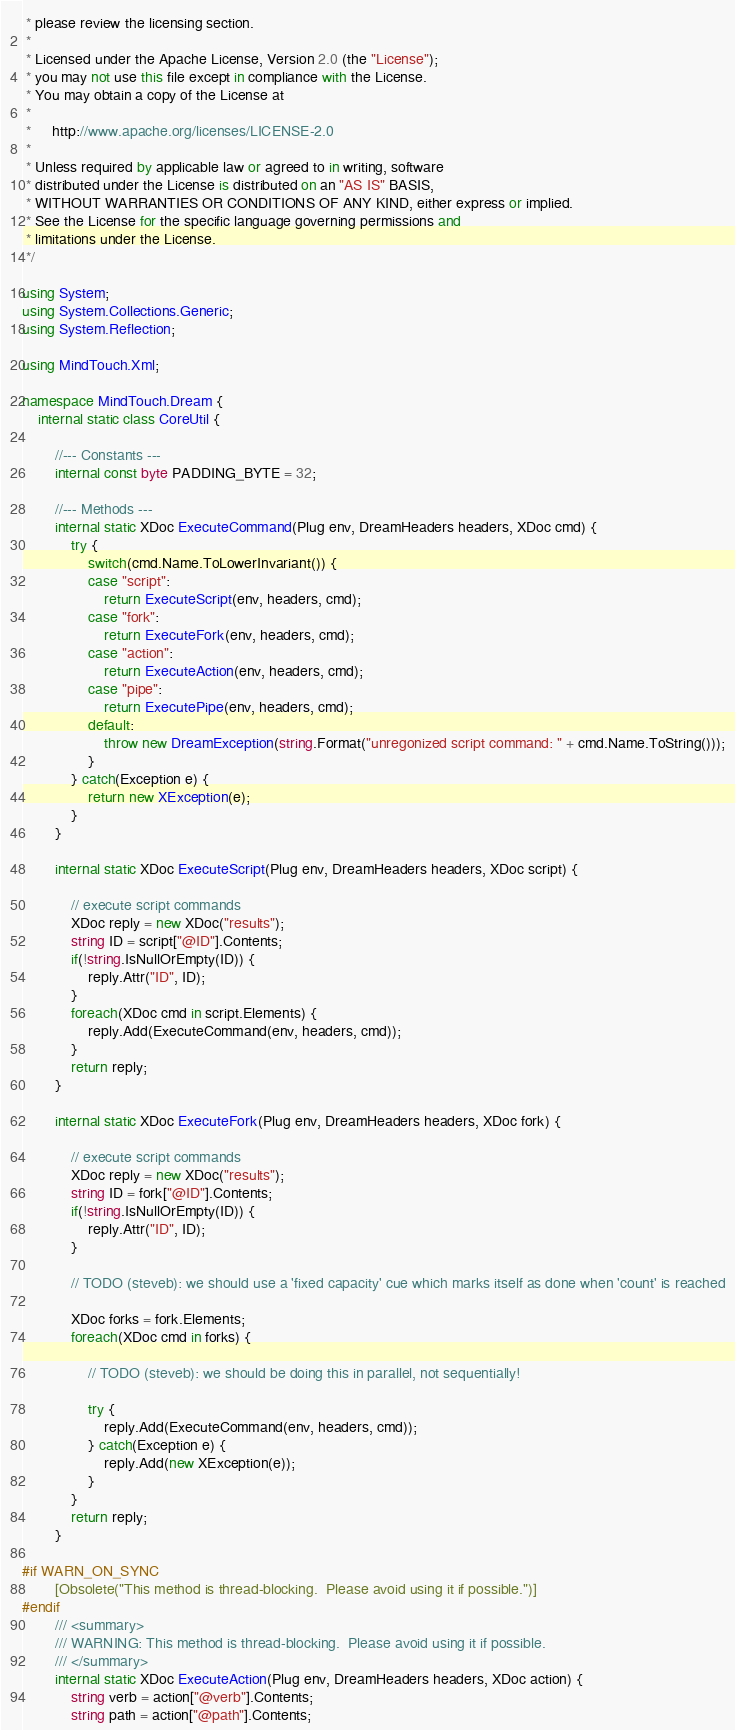Convert code to text. <code><loc_0><loc_0><loc_500><loc_500><_C#_> * please review the licensing section.
 *
 * Licensed under the Apache License, Version 2.0 (the "License");
 * you may not use this file except in compliance with the License.
 * You may obtain a copy of the License at
 * 
 *     http://www.apache.org/licenses/LICENSE-2.0
 * 
 * Unless required by applicable law or agreed to in writing, software
 * distributed under the License is distributed on an "AS IS" BASIS,
 * WITHOUT WARRANTIES OR CONDITIONS OF ANY KIND, either express or implied.
 * See the License for the specific language governing permissions and
 * limitations under the License.
 */

using System;
using System.Collections.Generic;
using System.Reflection;

using MindTouch.Xml;

namespace MindTouch.Dream {
    internal static class CoreUtil {

        //--- Constants ---
        internal const byte PADDING_BYTE = 32;

        //--- Methods ---
        internal static XDoc ExecuteCommand(Plug env, DreamHeaders headers, XDoc cmd) {
            try {
                switch(cmd.Name.ToLowerInvariant()) {
                case "script":
                    return ExecuteScript(env, headers, cmd);
                case "fork":
                    return ExecuteFork(env, headers, cmd);
                case "action":
                    return ExecuteAction(env, headers, cmd);
                case "pipe":
                    return ExecutePipe(env, headers, cmd);
                default:
                    throw new DreamException(string.Format("unregonized script command: " + cmd.Name.ToString()));
                }
            } catch(Exception e) {
                return new XException(e);
            }
        }

        internal static XDoc ExecuteScript(Plug env, DreamHeaders headers, XDoc script) {

            // execute script commands
            XDoc reply = new XDoc("results");
            string ID = script["@ID"].Contents;
            if(!string.IsNullOrEmpty(ID)) {
                reply.Attr("ID", ID);
            }
            foreach(XDoc cmd in script.Elements) {
                reply.Add(ExecuteCommand(env, headers, cmd));
            }
            return reply;
        }

        internal static XDoc ExecuteFork(Plug env, DreamHeaders headers, XDoc fork) {

            // execute script commands
            XDoc reply = new XDoc("results");
            string ID = fork["@ID"].Contents;
            if(!string.IsNullOrEmpty(ID)) {
                reply.Attr("ID", ID);
            }

            // TODO (steveb): we should use a 'fixed capacity' cue which marks itself as done when 'count' is reached

            XDoc forks = fork.Elements;
            foreach(XDoc cmd in forks) {

                // TODO (steveb): we should be doing this in parallel, not sequentially!

                try {
                    reply.Add(ExecuteCommand(env, headers, cmd));
                } catch(Exception e) {
                    reply.Add(new XException(e));
                }
            }
            return reply;
        }

#if WARN_ON_SYNC
        [Obsolete("This method is thread-blocking.  Please avoid using it if possible.")]
#endif
        /// <summary>
        /// WARNING: This method is thread-blocking.  Please avoid using it if possible.
        /// </summary>
        internal static XDoc ExecuteAction(Plug env, DreamHeaders headers, XDoc action) {
            string verb = action["@verb"].Contents;
            string path = action["@path"].Contents;</code> 